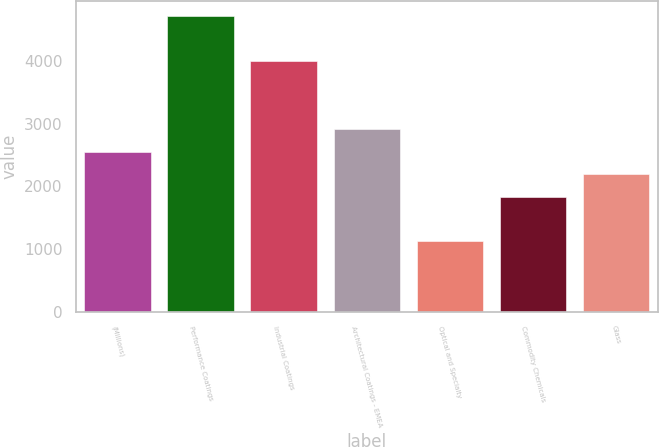Convert chart. <chart><loc_0><loc_0><loc_500><loc_500><bar_chart><fcel>(Millions)<fcel>Performance Coatings<fcel>Industrial Coatings<fcel>Architectural Coatings - EMEA<fcel>Optical and Specialty<fcel>Commodity Chemicals<fcel>Glass<nl><fcel>2553.4<fcel>4716<fcel>3999<fcel>2911.6<fcel>1134<fcel>1837<fcel>2195.2<nl></chart> 